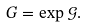Convert formula to latex. <formula><loc_0><loc_0><loc_500><loc_500>G = \exp \mathcal { G } .</formula> 